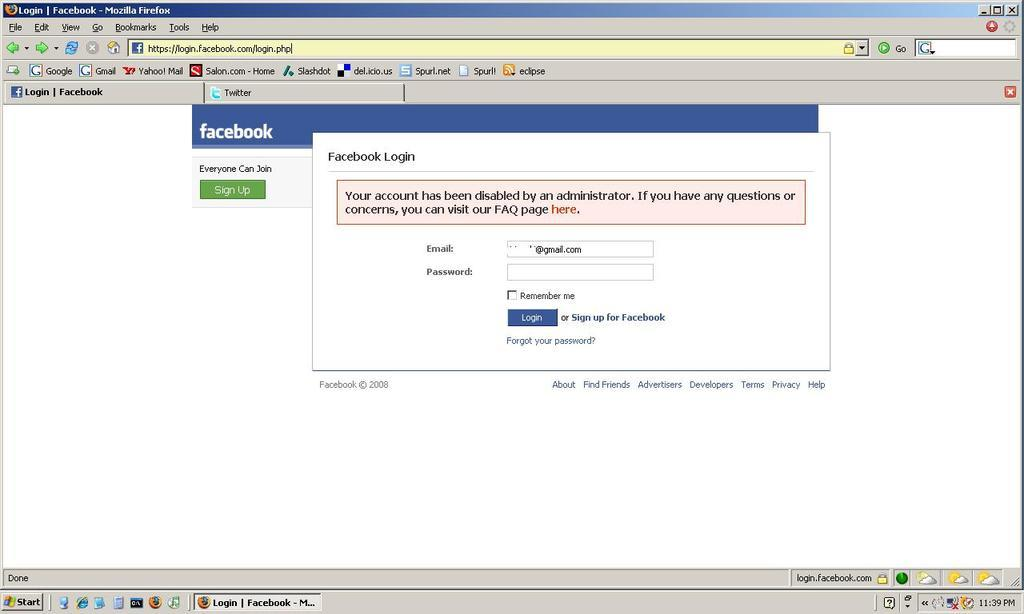<image>
Relay a brief, clear account of the picture shown. A screenshot of a Facebook login page that has a red error message saying 'your account has been disabled.' 